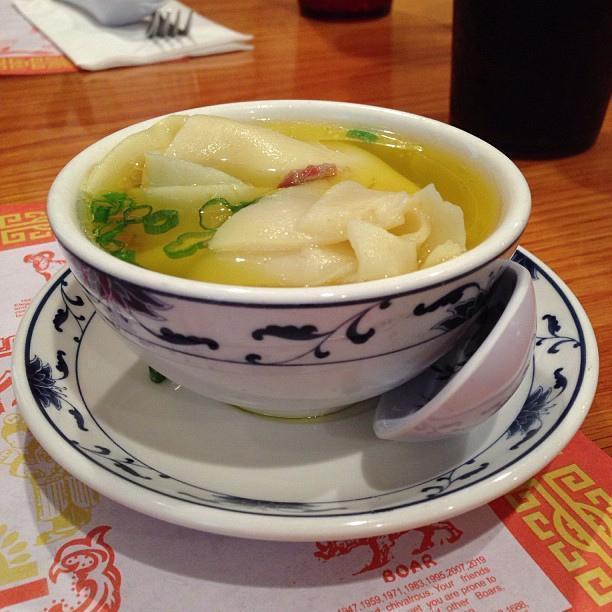What is traditionally eaten as an accompaniment to this dish?
Choose the correct response and explain in the format: 'Answer: answer
Rationale: rationale.'
Options: Bread, fruit, eggs, cake. Answer: bread.
Rationale: Bread is usually eaten with soup. 